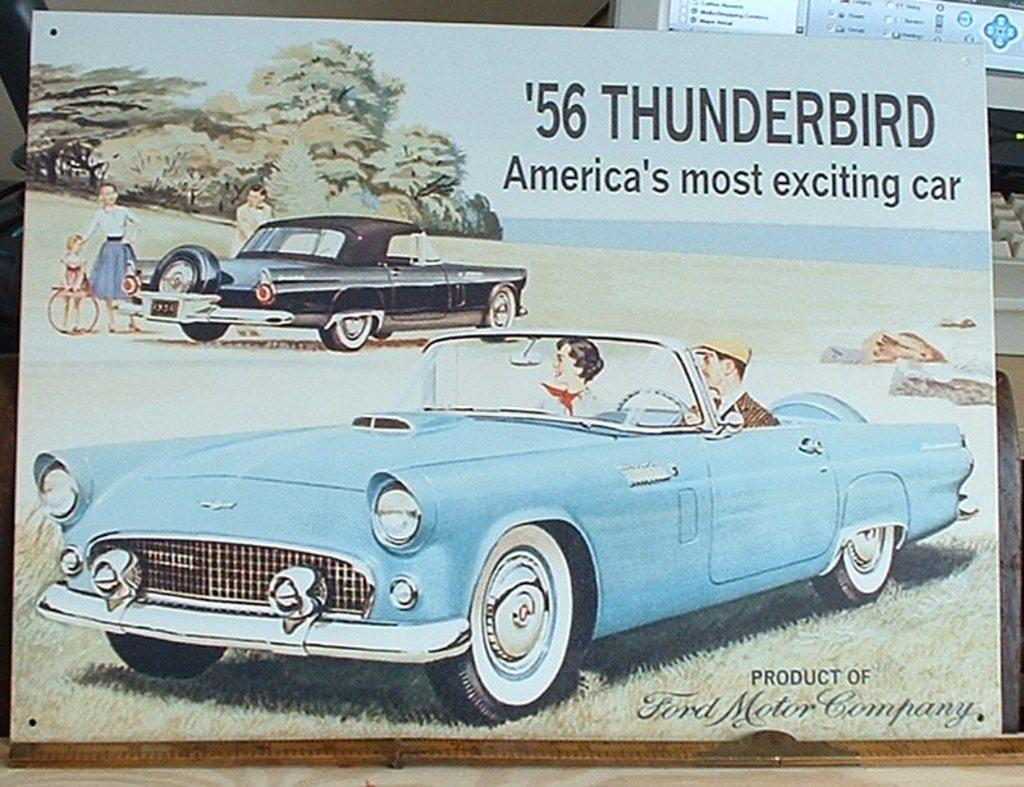What is depicted in the image? There is a cartoon picture of two cars in the image. Are there any characters or figures in the cartoon picture? Yes, there are people in the cartoon picture. What else can be seen in the image besides the cartoon picture? There is a computer visible behind the cartoon picture. What type of authority figure is present in the image? There is no authority figure present in the image; it features a cartoon picture of two cars and people, along with a computer visible in the background. 